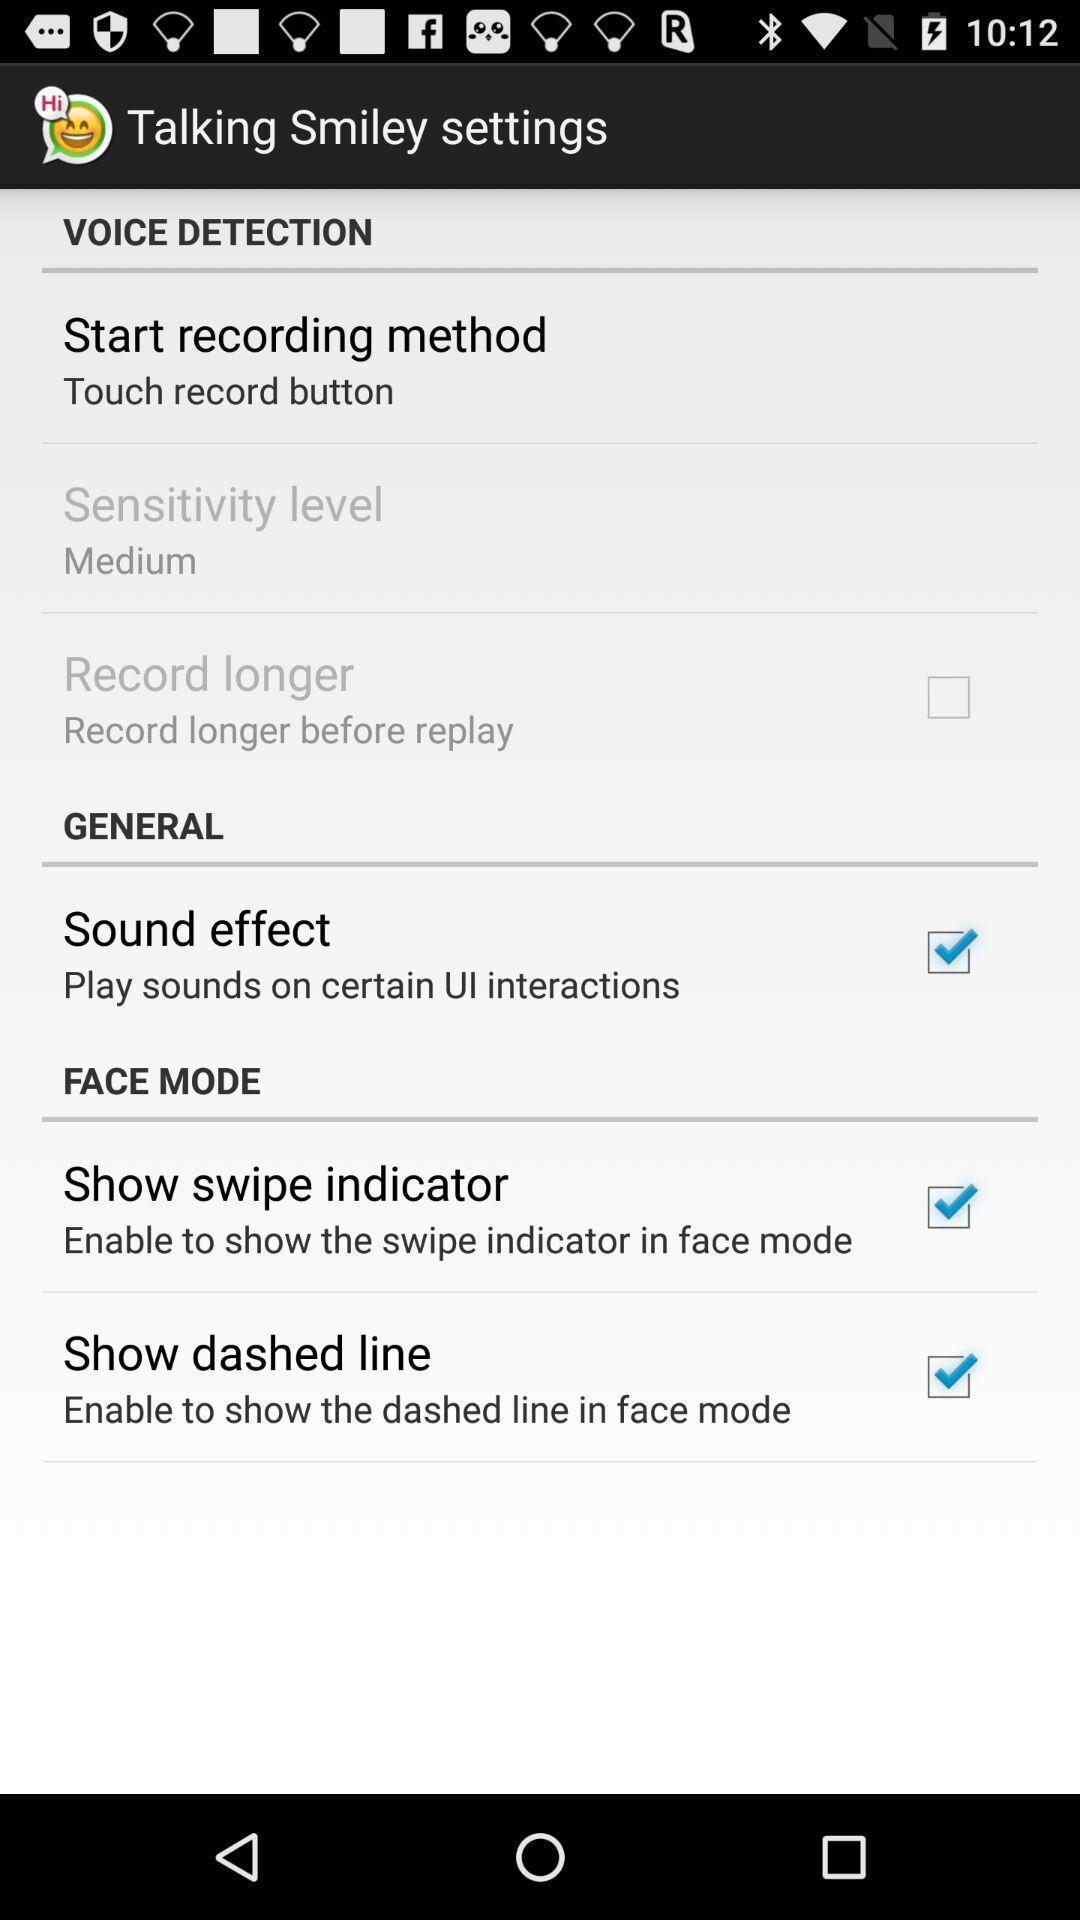Describe the content in this image. Screen displaying settings on smiley app. 